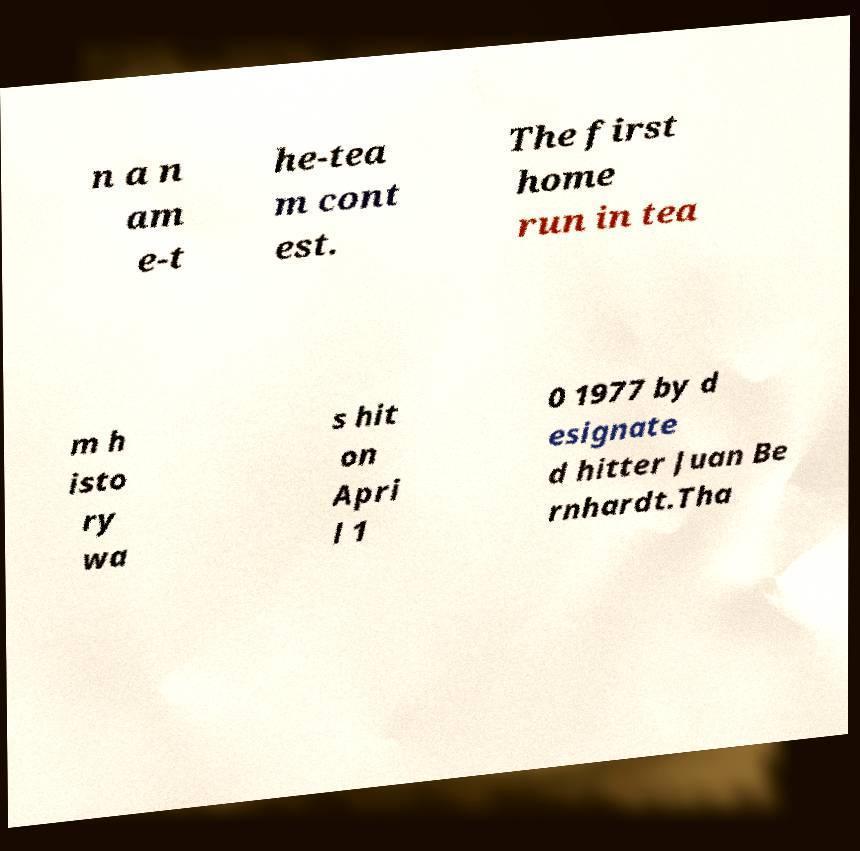Can you accurately transcribe the text from the provided image for me? n a n am e-t he-tea m cont est. The first home run in tea m h isto ry wa s hit on Apri l 1 0 1977 by d esignate d hitter Juan Be rnhardt.Tha 